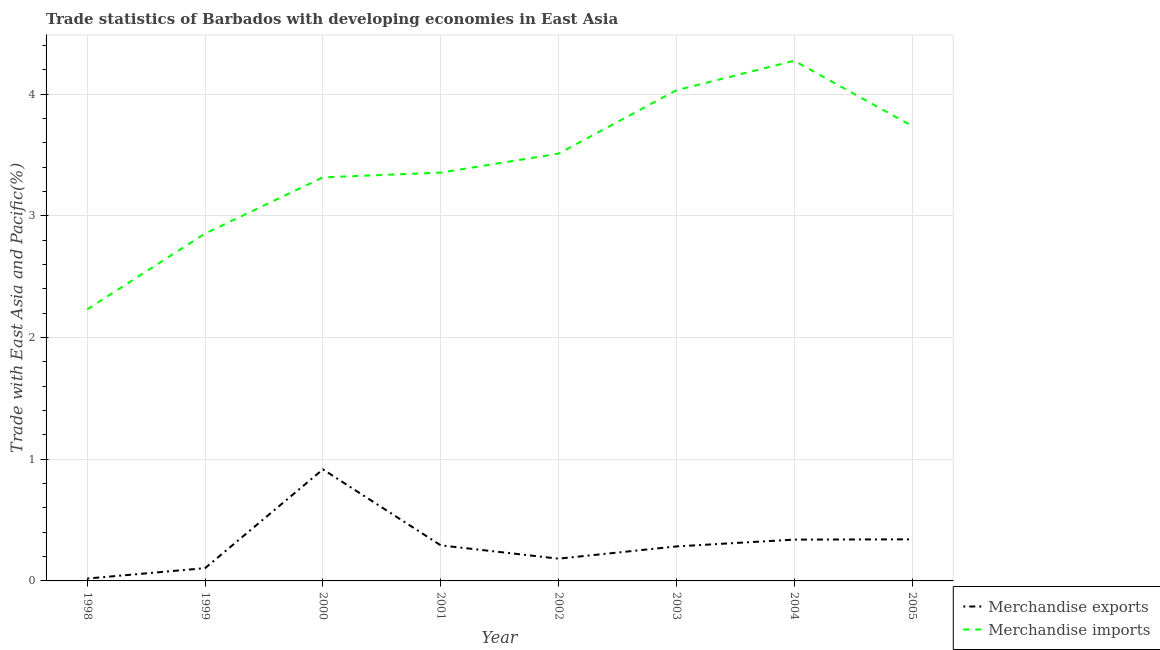Is the number of lines equal to the number of legend labels?
Your answer should be very brief. Yes. What is the merchandise imports in 2004?
Your response must be concise. 4.27. Across all years, what is the maximum merchandise imports?
Give a very brief answer. 4.27. Across all years, what is the minimum merchandise exports?
Your answer should be very brief. 0.02. In which year was the merchandise imports maximum?
Provide a succinct answer. 2004. In which year was the merchandise exports minimum?
Your answer should be very brief. 1998. What is the total merchandise imports in the graph?
Give a very brief answer. 27.32. What is the difference between the merchandise exports in 2001 and that in 2003?
Keep it short and to the point. 0.01. What is the difference between the merchandise exports in 2004 and the merchandise imports in 2002?
Offer a terse response. -3.17. What is the average merchandise exports per year?
Offer a very short reply. 0.31. In the year 2004, what is the difference between the merchandise exports and merchandise imports?
Keep it short and to the point. -3.93. In how many years, is the merchandise imports greater than 2.2 %?
Keep it short and to the point. 8. What is the ratio of the merchandise exports in 2001 to that in 2004?
Make the answer very short. 0.86. What is the difference between the highest and the second highest merchandise exports?
Provide a succinct answer. 0.57. What is the difference between the highest and the lowest merchandise exports?
Offer a terse response. 0.9. Is the merchandise exports strictly greater than the merchandise imports over the years?
Provide a short and direct response. No. Is the merchandise imports strictly less than the merchandise exports over the years?
Ensure brevity in your answer.  No. How many lines are there?
Your answer should be very brief. 2. What is the difference between two consecutive major ticks on the Y-axis?
Offer a very short reply. 1. Does the graph contain grids?
Offer a very short reply. Yes. How many legend labels are there?
Offer a terse response. 2. How are the legend labels stacked?
Ensure brevity in your answer.  Vertical. What is the title of the graph?
Make the answer very short. Trade statistics of Barbados with developing economies in East Asia. What is the label or title of the X-axis?
Provide a succinct answer. Year. What is the label or title of the Y-axis?
Make the answer very short. Trade with East Asia and Pacific(%). What is the Trade with East Asia and Pacific(%) of Merchandise exports in 1998?
Give a very brief answer. 0.02. What is the Trade with East Asia and Pacific(%) in Merchandise imports in 1998?
Your response must be concise. 2.23. What is the Trade with East Asia and Pacific(%) of Merchandise exports in 1999?
Your response must be concise. 0.1. What is the Trade with East Asia and Pacific(%) in Merchandise imports in 1999?
Provide a succinct answer. 2.85. What is the Trade with East Asia and Pacific(%) in Merchandise exports in 2000?
Your answer should be very brief. 0.92. What is the Trade with East Asia and Pacific(%) in Merchandise imports in 2000?
Keep it short and to the point. 3.32. What is the Trade with East Asia and Pacific(%) of Merchandise exports in 2001?
Ensure brevity in your answer.  0.29. What is the Trade with East Asia and Pacific(%) in Merchandise imports in 2001?
Provide a succinct answer. 3.36. What is the Trade with East Asia and Pacific(%) in Merchandise exports in 2002?
Ensure brevity in your answer.  0.18. What is the Trade with East Asia and Pacific(%) in Merchandise imports in 2002?
Provide a succinct answer. 3.51. What is the Trade with East Asia and Pacific(%) in Merchandise exports in 2003?
Ensure brevity in your answer.  0.28. What is the Trade with East Asia and Pacific(%) of Merchandise imports in 2003?
Offer a terse response. 4.03. What is the Trade with East Asia and Pacific(%) in Merchandise exports in 2004?
Offer a very short reply. 0.34. What is the Trade with East Asia and Pacific(%) in Merchandise imports in 2004?
Your answer should be compact. 4.27. What is the Trade with East Asia and Pacific(%) of Merchandise exports in 2005?
Make the answer very short. 0.34. What is the Trade with East Asia and Pacific(%) of Merchandise imports in 2005?
Offer a terse response. 3.74. Across all years, what is the maximum Trade with East Asia and Pacific(%) of Merchandise exports?
Provide a succinct answer. 0.92. Across all years, what is the maximum Trade with East Asia and Pacific(%) in Merchandise imports?
Your response must be concise. 4.27. Across all years, what is the minimum Trade with East Asia and Pacific(%) in Merchandise exports?
Your answer should be compact. 0.02. Across all years, what is the minimum Trade with East Asia and Pacific(%) of Merchandise imports?
Your answer should be compact. 2.23. What is the total Trade with East Asia and Pacific(%) of Merchandise exports in the graph?
Offer a terse response. 2.48. What is the total Trade with East Asia and Pacific(%) in Merchandise imports in the graph?
Give a very brief answer. 27.32. What is the difference between the Trade with East Asia and Pacific(%) in Merchandise exports in 1998 and that in 1999?
Keep it short and to the point. -0.09. What is the difference between the Trade with East Asia and Pacific(%) of Merchandise imports in 1998 and that in 1999?
Make the answer very short. -0.62. What is the difference between the Trade with East Asia and Pacific(%) of Merchandise exports in 1998 and that in 2000?
Give a very brief answer. -0.9. What is the difference between the Trade with East Asia and Pacific(%) in Merchandise imports in 1998 and that in 2000?
Offer a very short reply. -1.08. What is the difference between the Trade with East Asia and Pacific(%) in Merchandise exports in 1998 and that in 2001?
Make the answer very short. -0.27. What is the difference between the Trade with East Asia and Pacific(%) of Merchandise imports in 1998 and that in 2001?
Provide a short and direct response. -1.12. What is the difference between the Trade with East Asia and Pacific(%) in Merchandise exports in 1998 and that in 2002?
Offer a very short reply. -0.16. What is the difference between the Trade with East Asia and Pacific(%) of Merchandise imports in 1998 and that in 2002?
Ensure brevity in your answer.  -1.28. What is the difference between the Trade with East Asia and Pacific(%) of Merchandise exports in 1998 and that in 2003?
Offer a terse response. -0.26. What is the difference between the Trade with East Asia and Pacific(%) in Merchandise imports in 1998 and that in 2003?
Your answer should be very brief. -1.8. What is the difference between the Trade with East Asia and Pacific(%) of Merchandise exports in 1998 and that in 2004?
Your response must be concise. -0.32. What is the difference between the Trade with East Asia and Pacific(%) in Merchandise imports in 1998 and that in 2004?
Your answer should be compact. -2.04. What is the difference between the Trade with East Asia and Pacific(%) in Merchandise exports in 1998 and that in 2005?
Ensure brevity in your answer.  -0.32. What is the difference between the Trade with East Asia and Pacific(%) in Merchandise imports in 1998 and that in 2005?
Your response must be concise. -1.51. What is the difference between the Trade with East Asia and Pacific(%) in Merchandise exports in 1999 and that in 2000?
Make the answer very short. -0.81. What is the difference between the Trade with East Asia and Pacific(%) of Merchandise imports in 1999 and that in 2000?
Provide a short and direct response. -0.46. What is the difference between the Trade with East Asia and Pacific(%) of Merchandise exports in 1999 and that in 2001?
Offer a very short reply. -0.19. What is the difference between the Trade with East Asia and Pacific(%) in Merchandise imports in 1999 and that in 2001?
Ensure brevity in your answer.  -0.5. What is the difference between the Trade with East Asia and Pacific(%) in Merchandise exports in 1999 and that in 2002?
Your response must be concise. -0.08. What is the difference between the Trade with East Asia and Pacific(%) of Merchandise imports in 1999 and that in 2002?
Provide a succinct answer. -0.66. What is the difference between the Trade with East Asia and Pacific(%) in Merchandise exports in 1999 and that in 2003?
Give a very brief answer. -0.18. What is the difference between the Trade with East Asia and Pacific(%) of Merchandise imports in 1999 and that in 2003?
Your answer should be compact. -1.18. What is the difference between the Trade with East Asia and Pacific(%) in Merchandise exports in 1999 and that in 2004?
Make the answer very short. -0.23. What is the difference between the Trade with East Asia and Pacific(%) in Merchandise imports in 1999 and that in 2004?
Keep it short and to the point. -1.42. What is the difference between the Trade with East Asia and Pacific(%) of Merchandise exports in 1999 and that in 2005?
Keep it short and to the point. -0.24. What is the difference between the Trade with East Asia and Pacific(%) of Merchandise imports in 1999 and that in 2005?
Make the answer very short. -0.88. What is the difference between the Trade with East Asia and Pacific(%) in Merchandise exports in 2000 and that in 2001?
Your response must be concise. 0.62. What is the difference between the Trade with East Asia and Pacific(%) of Merchandise imports in 2000 and that in 2001?
Provide a succinct answer. -0.04. What is the difference between the Trade with East Asia and Pacific(%) in Merchandise exports in 2000 and that in 2002?
Keep it short and to the point. 0.73. What is the difference between the Trade with East Asia and Pacific(%) in Merchandise imports in 2000 and that in 2002?
Give a very brief answer. -0.2. What is the difference between the Trade with East Asia and Pacific(%) of Merchandise exports in 2000 and that in 2003?
Provide a succinct answer. 0.63. What is the difference between the Trade with East Asia and Pacific(%) of Merchandise imports in 2000 and that in 2003?
Offer a terse response. -0.72. What is the difference between the Trade with East Asia and Pacific(%) of Merchandise exports in 2000 and that in 2004?
Your response must be concise. 0.58. What is the difference between the Trade with East Asia and Pacific(%) in Merchandise imports in 2000 and that in 2004?
Provide a succinct answer. -0.96. What is the difference between the Trade with East Asia and Pacific(%) in Merchandise exports in 2000 and that in 2005?
Make the answer very short. 0.57. What is the difference between the Trade with East Asia and Pacific(%) of Merchandise imports in 2000 and that in 2005?
Provide a short and direct response. -0.42. What is the difference between the Trade with East Asia and Pacific(%) in Merchandise exports in 2001 and that in 2002?
Keep it short and to the point. 0.11. What is the difference between the Trade with East Asia and Pacific(%) in Merchandise imports in 2001 and that in 2002?
Ensure brevity in your answer.  -0.16. What is the difference between the Trade with East Asia and Pacific(%) in Merchandise exports in 2001 and that in 2003?
Give a very brief answer. 0.01. What is the difference between the Trade with East Asia and Pacific(%) in Merchandise imports in 2001 and that in 2003?
Your answer should be very brief. -0.68. What is the difference between the Trade with East Asia and Pacific(%) of Merchandise exports in 2001 and that in 2004?
Offer a terse response. -0.05. What is the difference between the Trade with East Asia and Pacific(%) of Merchandise imports in 2001 and that in 2004?
Your response must be concise. -0.92. What is the difference between the Trade with East Asia and Pacific(%) of Merchandise exports in 2001 and that in 2005?
Provide a short and direct response. -0.05. What is the difference between the Trade with East Asia and Pacific(%) in Merchandise imports in 2001 and that in 2005?
Provide a succinct answer. -0.38. What is the difference between the Trade with East Asia and Pacific(%) of Merchandise exports in 2002 and that in 2003?
Make the answer very short. -0.1. What is the difference between the Trade with East Asia and Pacific(%) in Merchandise imports in 2002 and that in 2003?
Provide a short and direct response. -0.52. What is the difference between the Trade with East Asia and Pacific(%) in Merchandise exports in 2002 and that in 2004?
Keep it short and to the point. -0.16. What is the difference between the Trade with East Asia and Pacific(%) in Merchandise imports in 2002 and that in 2004?
Provide a short and direct response. -0.76. What is the difference between the Trade with East Asia and Pacific(%) in Merchandise exports in 2002 and that in 2005?
Make the answer very short. -0.16. What is the difference between the Trade with East Asia and Pacific(%) in Merchandise imports in 2002 and that in 2005?
Keep it short and to the point. -0.23. What is the difference between the Trade with East Asia and Pacific(%) of Merchandise exports in 2003 and that in 2004?
Keep it short and to the point. -0.06. What is the difference between the Trade with East Asia and Pacific(%) in Merchandise imports in 2003 and that in 2004?
Keep it short and to the point. -0.24. What is the difference between the Trade with East Asia and Pacific(%) of Merchandise exports in 2003 and that in 2005?
Ensure brevity in your answer.  -0.06. What is the difference between the Trade with East Asia and Pacific(%) of Merchandise imports in 2003 and that in 2005?
Give a very brief answer. 0.29. What is the difference between the Trade with East Asia and Pacific(%) of Merchandise exports in 2004 and that in 2005?
Make the answer very short. -0. What is the difference between the Trade with East Asia and Pacific(%) of Merchandise imports in 2004 and that in 2005?
Your response must be concise. 0.54. What is the difference between the Trade with East Asia and Pacific(%) in Merchandise exports in 1998 and the Trade with East Asia and Pacific(%) in Merchandise imports in 1999?
Keep it short and to the point. -2.84. What is the difference between the Trade with East Asia and Pacific(%) in Merchandise exports in 1998 and the Trade with East Asia and Pacific(%) in Merchandise imports in 2000?
Ensure brevity in your answer.  -3.3. What is the difference between the Trade with East Asia and Pacific(%) in Merchandise exports in 1998 and the Trade with East Asia and Pacific(%) in Merchandise imports in 2001?
Provide a short and direct response. -3.34. What is the difference between the Trade with East Asia and Pacific(%) in Merchandise exports in 1998 and the Trade with East Asia and Pacific(%) in Merchandise imports in 2002?
Offer a terse response. -3.49. What is the difference between the Trade with East Asia and Pacific(%) in Merchandise exports in 1998 and the Trade with East Asia and Pacific(%) in Merchandise imports in 2003?
Give a very brief answer. -4.01. What is the difference between the Trade with East Asia and Pacific(%) in Merchandise exports in 1998 and the Trade with East Asia and Pacific(%) in Merchandise imports in 2004?
Give a very brief answer. -4.25. What is the difference between the Trade with East Asia and Pacific(%) in Merchandise exports in 1998 and the Trade with East Asia and Pacific(%) in Merchandise imports in 2005?
Your answer should be very brief. -3.72. What is the difference between the Trade with East Asia and Pacific(%) in Merchandise exports in 1999 and the Trade with East Asia and Pacific(%) in Merchandise imports in 2000?
Make the answer very short. -3.21. What is the difference between the Trade with East Asia and Pacific(%) in Merchandise exports in 1999 and the Trade with East Asia and Pacific(%) in Merchandise imports in 2001?
Provide a short and direct response. -3.25. What is the difference between the Trade with East Asia and Pacific(%) in Merchandise exports in 1999 and the Trade with East Asia and Pacific(%) in Merchandise imports in 2002?
Provide a succinct answer. -3.41. What is the difference between the Trade with East Asia and Pacific(%) of Merchandise exports in 1999 and the Trade with East Asia and Pacific(%) of Merchandise imports in 2003?
Keep it short and to the point. -3.93. What is the difference between the Trade with East Asia and Pacific(%) of Merchandise exports in 1999 and the Trade with East Asia and Pacific(%) of Merchandise imports in 2004?
Offer a very short reply. -4.17. What is the difference between the Trade with East Asia and Pacific(%) in Merchandise exports in 1999 and the Trade with East Asia and Pacific(%) in Merchandise imports in 2005?
Keep it short and to the point. -3.63. What is the difference between the Trade with East Asia and Pacific(%) of Merchandise exports in 2000 and the Trade with East Asia and Pacific(%) of Merchandise imports in 2001?
Provide a short and direct response. -2.44. What is the difference between the Trade with East Asia and Pacific(%) in Merchandise exports in 2000 and the Trade with East Asia and Pacific(%) in Merchandise imports in 2002?
Offer a very short reply. -2.59. What is the difference between the Trade with East Asia and Pacific(%) of Merchandise exports in 2000 and the Trade with East Asia and Pacific(%) of Merchandise imports in 2003?
Offer a very short reply. -3.12. What is the difference between the Trade with East Asia and Pacific(%) in Merchandise exports in 2000 and the Trade with East Asia and Pacific(%) in Merchandise imports in 2004?
Your answer should be compact. -3.36. What is the difference between the Trade with East Asia and Pacific(%) of Merchandise exports in 2000 and the Trade with East Asia and Pacific(%) of Merchandise imports in 2005?
Your answer should be compact. -2.82. What is the difference between the Trade with East Asia and Pacific(%) of Merchandise exports in 2001 and the Trade with East Asia and Pacific(%) of Merchandise imports in 2002?
Your answer should be compact. -3.22. What is the difference between the Trade with East Asia and Pacific(%) of Merchandise exports in 2001 and the Trade with East Asia and Pacific(%) of Merchandise imports in 2003?
Give a very brief answer. -3.74. What is the difference between the Trade with East Asia and Pacific(%) in Merchandise exports in 2001 and the Trade with East Asia and Pacific(%) in Merchandise imports in 2004?
Your answer should be very brief. -3.98. What is the difference between the Trade with East Asia and Pacific(%) in Merchandise exports in 2001 and the Trade with East Asia and Pacific(%) in Merchandise imports in 2005?
Provide a short and direct response. -3.45. What is the difference between the Trade with East Asia and Pacific(%) of Merchandise exports in 2002 and the Trade with East Asia and Pacific(%) of Merchandise imports in 2003?
Offer a terse response. -3.85. What is the difference between the Trade with East Asia and Pacific(%) of Merchandise exports in 2002 and the Trade with East Asia and Pacific(%) of Merchandise imports in 2004?
Give a very brief answer. -4.09. What is the difference between the Trade with East Asia and Pacific(%) of Merchandise exports in 2002 and the Trade with East Asia and Pacific(%) of Merchandise imports in 2005?
Offer a terse response. -3.56. What is the difference between the Trade with East Asia and Pacific(%) in Merchandise exports in 2003 and the Trade with East Asia and Pacific(%) in Merchandise imports in 2004?
Offer a very short reply. -3.99. What is the difference between the Trade with East Asia and Pacific(%) of Merchandise exports in 2003 and the Trade with East Asia and Pacific(%) of Merchandise imports in 2005?
Give a very brief answer. -3.46. What is the difference between the Trade with East Asia and Pacific(%) in Merchandise exports in 2004 and the Trade with East Asia and Pacific(%) in Merchandise imports in 2005?
Offer a very short reply. -3.4. What is the average Trade with East Asia and Pacific(%) of Merchandise exports per year?
Ensure brevity in your answer.  0.31. What is the average Trade with East Asia and Pacific(%) in Merchandise imports per year?
Ensure brevity in your answer.  3.41. In the year 1998, what is the difference between the Trade with East Asia and Pacific(%) in Merchandise exports and Trade with East Asia and Pacific(%) in Merchandise imports?
Ensure brevity in your answer.  -2.21. In the year 1999, what is the difference between the Trade with East Asia and Pacific(%) of Merchandise exports and Trade with East Asia and Pacific(%) of Merchandise imports?
Your answer should be compact. -2.75. In the year 2000, what is the difference between the Trade with East Asia and Pacific(%) in Merchandise exports and Trade with East Asia and Pacific(%) in Merchandise imports?
Offer a very short reply. -2.4. In the year 2001, what is the difference between the Trade with East Asia and Pacific(%) in Merchandise exports and Trade with East Asia and Pacific(%) in Merchandise imports?
Your answer should be compact. -3.06. In the year 2002, what is the difference between the Trade with East Asia and Pacific(%) of Merchandise exports and Trade with East Asia and Pacific(%) of Merchandise imports?
Your response must be concise. -3.33. In the year 2003, what is the difference between the Trade with East Asia and Pacific(%) in Merchandise exports and Trade with East Asia and Pacific(%) in Merchandise imports?
Your answer should be compact. -3.75. In the year 2004, what is the difference between the Trade with East Asia and Pacific(%) in Merchandise exports and Trade with East Asia and Pacific(%) in Merchandise imports?
Provide a short and direct response. -3.94. In the year 2005, what is the difference between the Trade with East Asia and Pacific(%) of Merchandise exports and Trade with East Asia and Pacific(%) of Merchandise imports?
Provide a succinct answer. -3.4. What is the ratio of the Trade with East Asia and Pacific(%) of Merchandise exports in 1998 to that in 1999?
Keep it short and to the point. 0.19. What is the ratio of the Trade with East Asia and Pacific(%) in Merchandise imports in 1998 to that in 1999?
Give a very brief answer. 0.78. What is the ratio of the Trade with East Asia and Pacific(%) of Merchandise exports in 1998 to that in 2000?
Your answer should be compact. 0.02. What is the ratio of the Trade with East Asia and Pacific(%) of Merchandise imports in 1998 to that in 2000?
Provide a succinct answer. 0.67. What is the ratio of the Trade with East Asia and Pacific(%) of Merchandise exports in 1998 to that in 2001?
Make the answer very short. 0.07. What is the ratio of the Trade with East Asia and Pacific(%) of Merchandise imports in 1998 to that in 2001?
Make the answer very short. 0.67. What is the ratio of the Trade with East Asia and Pacific(%) in Merchandise exports in 1998 to that in 2002?
Your answer should be very brief. 0.11. What is the ratio of the Trade with East Asia and Pacific(%) in Merchandise imports in 1998 to that in 2002?
Offer a terse response. 0.64. What is the ratio of the Trade with East Asia and Pacific(%) of Merchandise exports in 1998 to that in 2003?
Ensure brevity in your answer.  0.07. What is the ratio of the Trade with East Asia and Pacific(%) of Merchandise imports in 1998 to that in 2003?
Your answer should be compact. 0.55. What is the ratio of the Trade with East Asia and Pacific(%) of Merchandise exports in 1998 to that in 2004?
Give a very brief answer. 0.06. What is the ratio of the Trade with East Asia and Pacific(%) in Merchandise imports in 1998 to that in 2004?
Your answer should be very brief. 0.52. What is the ratio of the Trade with East Asia and Pacific(%) in Merchandise exports in 1998 to that in 2005?
Give a very brief answer. 0.06. What is the ratio of the Trade with East Asia and Pacific(%) in Merchandise imports in 1998 to that in 2005?
Your answer should be very brief. 0.6. What is the ratio of the Trade with East Asia and Pacific(%) in Merchandise exports in 1999 to that in 2000?
Your answer should be compact. 0.11. What is the ratio of the Trade with East Asia and Pacific(%) of Merchandise imports in 1999 to that in 2000?
Ensure brevity in your answer.  0.86. What is the ratio of the Trade with East Asia and Pacific(%) of Merchandise exports in 1999 to that in 2001?
Your answer should be compact. 0.36. What is the ratio of the Trade with East Asia and Pacific(%) in Merchandise imports in 1999 to that in 2001?
Provide a succinct answer. 0.85. What is the ratio of the Trade with East Asia and Pacific(%) of Merchandise exports in 1999 to that in 2002?
Ensure brevity in your answer.  0.57. What is the ratio of the Trade with East Asia and Pacific(%) in Merchandise imports in 1999 to that in 2002?
Provide a short and direct response. 0.81. What is the ratio of the Trade with East Asia and Pacific(%) of Merchandise exports in 1999 to that in 2003?
Provide a succinct answer. 0.37. What is the ratio of the Trade with East Asia and Pacific(%) of Merchandise imports in 1999 to that in 2003?
Provide a succinct answer. 0.71. What is the ratio of the Trade with East Asia and Pacific(%) in Merchandise exports in 1999 to that in 2004?
Your answer should be very brief. 0.31. What is the ratio of the Trade with East Asia and Pacific(%) in Merchandise imports in 1999 to that in 2004?
Ensure brevity in your answer.  0.67. What is the ratio of the Trade with East Asia and Pacific(%) in Merchandise exports in 1999 to that in 2005?
Your response must be concise. 0.31. What is the ratio of the Trade with East Asia and Pacific(%) in Merchandise imports in 1999 to that in 2005?
Provide a short and direct response. 0.76. What is the ratio of the Trade with East Asia and Pacific(%) of Merchandise exports in 2000 to that in 2001?
Your answer should be very brief. 3.14. What is the ratio of the Trade with East Asia and Pacific(%) in Merchandise imports in 2000 to that in 2001?
Your response must be concise. 0.99. What is the ratio of the Trade with East Asia and Pacific(%) in Merchandise exports in 2000 to that in 2002?
Provide a short and direct response. 5.01. What is the ratio of the Trade with East Asia and Pacific(%) in Merchandise imports in 2000 to that in 2002?
Offer a terse response. 0.94. What is the ratio of the Trade with East Asia and Pacific(%) of Merchandise exports in 2000 to that in 2003?
Ensure brevity in your answer.  3.23. What is the ratio of the Trade with East Asia and Pacific(%) of Merchandise imports in 2000 to that in 2003?
Give a very brief answer. 0.82. What is the ratio of the Trade with East Asia and Pacific(%) of Merchandise exports in 2000 to that in 2004?
Keep it short and to the point. 2.7. What is the ratio of the Trade with East Asia and Pacific(%) in Merchandise imports in 2000 to that in 2004?
Give a very brief answer. 0.78. What is the ratio of the Trade with East Asia and Pacific(%) of Merchandise exports in 2000 to that in 2005?
Provide a succinct answer. 2.68. What is the ratio of the Trade with East Asia and Pacific(%) of Merchandise imports in 2000 to that in 2005?
Keep it short and to the point. 0.89. What is the ratio of the Trade with East Asia and Pacific(%) of Merchandise exports in 2001 to that in 2002?
Provide a short and direct response. 1.6. What is the ratio of the Trade with East Asia and Pacific(%) of Merchandise imports in 2001 to that in 2002?
Keep it short and to the point. 0.96. What is the ratio of the Trade with East Asia and Pacific(%) in Merchandise exports in 2001 to that in 2003?
Provide a short and direct response. 1.03. What is the ratio of the Trade with East Asia and Pacific(%) in Merchandise imports in 2001 to that in 2003?
Your answer should be compact. 0.83. What is the ratio of the Trade with East Asia and Pacific(%) in Merchandise exports in 2001 to that in 2004?
Ensure brevity in your answer.  0.86. What is the ratio of the Trade with East Asia and Pacific(%) in Merchandise imports in 2001 to that in 2004?
Keep it short and to the point. 0.79. What is the ratio of the Trade with East Asia and Pacific(%) of Merchandise exports in 2001 to that in 2005?
Your response must be concise. 0.86. What is the ratio of the Trade with East Asia and Pacific(%) of Merchandise imports in 2001 to that in 2005?
Ensure brevity in your answer.  0.9. What is the ratio of the Trade with East Asia and Pacific(%) in Merchandise exports in 2002 to that in 2003?
Offer a terse response. 0.64. What is the ratio of the Trade with East Asia and Pacific(%) of Merchandise imports in 2002 to that in 2003?
Offer a terse response. 0.87. What is the ratio of the Trade with East Asia and Pacific(%) in Merchandise exports in 2002 to that in 2004?
Offer a very short reply. 0.54. What is the ratio of the Trade with East Asia and Pacific(%) in Merchandise imports in 2002 to that in 2004?
Make the answer very short. 0.82. What is the ratio of the Trade with East Asia and Pacific(%) in Merchandise exports in 2002 to that in 2005?
Provide a succinct answer. 0.53. What is the ratio of the Trade with East Asia and Pacific(%) in Merchandise imports in 2002 to that in 2005?
Offer a very short reply. 0.94. What is the ratio of the Trade with East Asia and Pacific(%) of Merchandise exports in 2003 to that in 2004?
Offer a terse response. 0.83. What is the ratio of the Trade with East Asia and Pacific(%) in Merchandise imports in 2003 to that in 2004?
Offer a very short reply. 0.94. What is the ratio of the Trade with East Asia and Pacific(%) of Merchandise exports in 2003 to that in 2005?
Provide a short and direct response. 0.83. What is the ratio of the Trade with East Asia and Pacific(%) in Merchandise imports in 2003 to that in 2005?
Give a very brief answer. 1.08. What is the ratio of the Trade with East Asia and Pacific(%) of Merchandise imports in 2004 to that in 2005?
Offer a very short reply. 1.14. What is the difference between the highest and the second highest Trade with East Asia and Pacific(%) in Merchandise exports?
Keep it short and to the point. 0.57. What is the difference between the highest and the second highest Trade with East Asia and Pacific(%) in Merchandise imports?
Offer a very short reply. 0.24. What is the difference between the highest and the lowest Trade with East Asia and Pacific(%) of Merchandise exports?
Give a very brief answer. 0.9. What is the difference between the highest and the lowest Trade with East Asia and Pacific(%) in Merchandise imports?
Your answer should be compact. 2.04. 